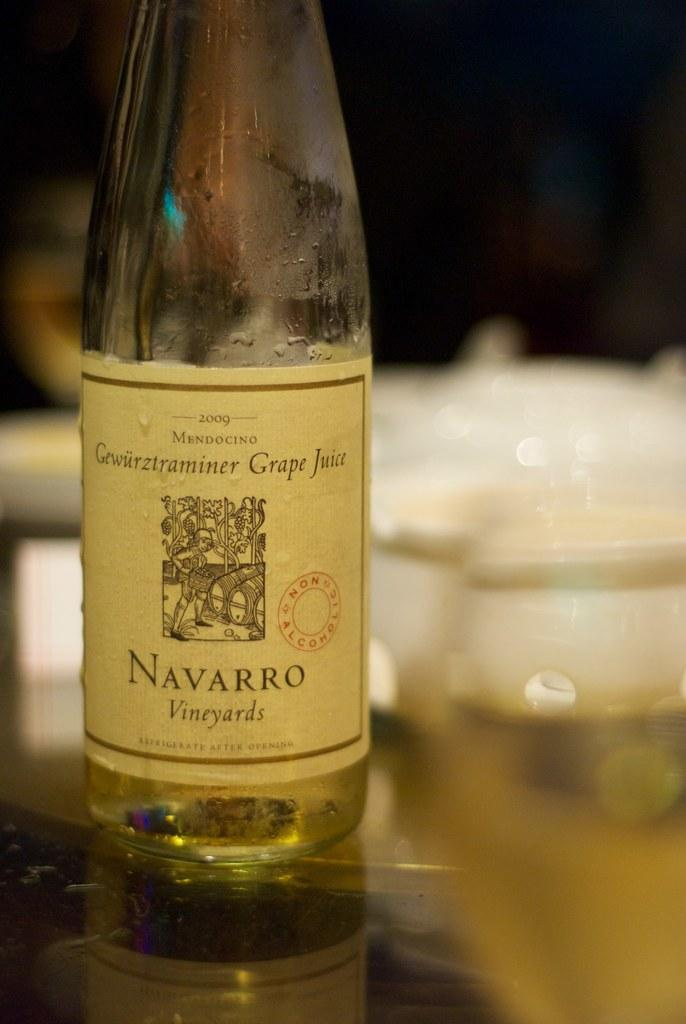What type of beverage is in the bottle in the image? The bottle in the image contains grape juice. What type of curtain is hanging near the bottle in the image? There is no curtain present in the image; it only features a bottle labeled as grape juice. 